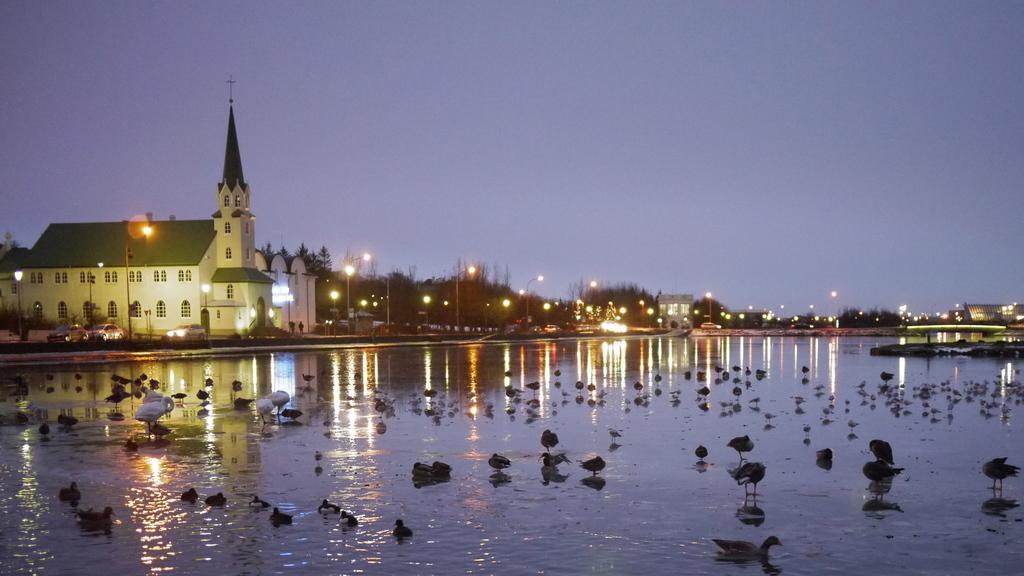How would you summarize this image in a sentence or two? In this image we can see some birds on the water. On the backside we can see a house with roof and windows. We can also see some trees, poles with lights and the sky which looks cloudy. 